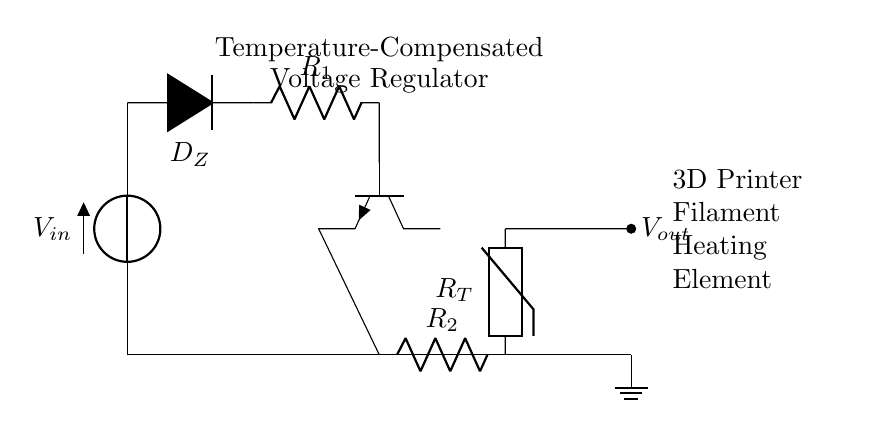What is the input voltage of this circuit? The input voltage is represented by the symbol V_in, which is shown at the top left of the circuit diagram.
Answer: V_in What type of diode is used in this circuit? The circuit uses a Zener diode, indicated by the label D_Z next to the diode symbol.
Answer: Zener diode How many resistors are present in the circuit? There are two resistors present, labeled R_1 and R_2 in the circuit diagram located at different positions.
Answer: Two What is the role of the thermistor in this circuit? The thermistor, labeled R_T, is used for temperature sensing, providing feedback for temperature compensation.
Answer: Temperature sensing What is the output voltage's purpose in this circuit? The output voltage, labeled V_out, is intended to supply power to the 3D printer filament heating element as indicated by the notes on the right side of the diagram.
Answer: Power supply for heating element How does the transistor function in this voltage regulator circuit? The transistor, labeled Q1, acts as a switch or amplifier to regulate the voltage by controlling the current through it based on the feedback from the thermistor.
Answer: Regulates voltage 